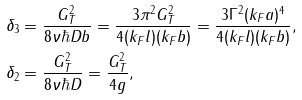<formula> <loc_0><loc_0><loc_500><loc_500>& \delta _ { 3 } = \frac { G _ { T } ^ { 2 } } { 8 \nu \hbar { D } b } = \frac { 3 \pi ^ { 2 } G _ { T } ^ { 2 } } { 4 ( k _ { F } l ) ( k _ { F } b ) } = \frac { 3 \Gamma ^ { 2 } ( k _ { F } a ) ^ { 4 } } { 4 ( k _ { F } l ) ( k _ { F } b ) } , \\ & \delta _ { 2 } = \frac { G _ { T } ^ { 2 } } { 8 \nu \hbar { D } } = \frac { G _ { T } ^ { 2 } } { 4 g } ,</formula> 